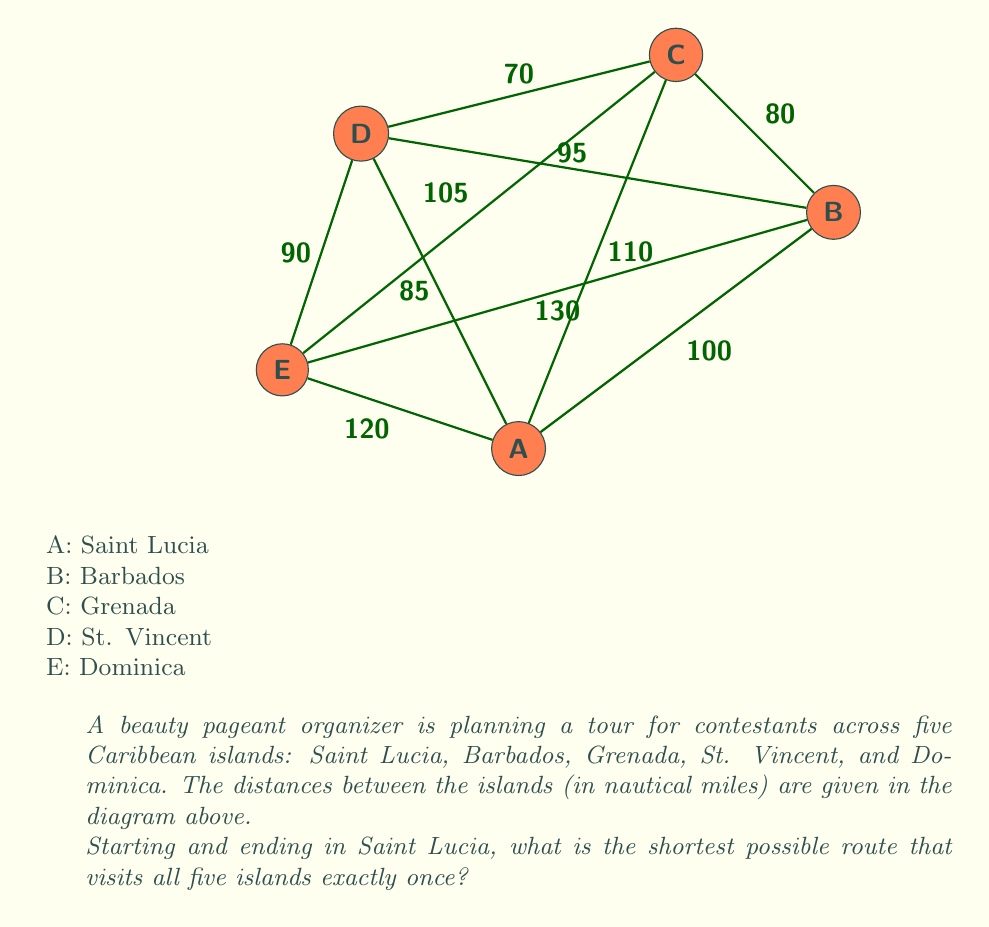Give your solution to this math problem. To solve this problem, we need to find the shortest Hamiltonian cycle in the given graph, which is known as the Traveling Salesman Problem (TSP). For a small number of nodes like this, we can use a brute-force approach.

Steps:
1) List all possible routes starting and ending in Saint Lucia (A):
   There are $(5-1)! = 24$ possible routes.

2) Calculate the total distance for each route:
   For example, A-B-C-D-E-A = 100 + 80 + 70 + 90 + 120 = 460 nm

3) Compare all routes and find the shortest one.

After calculating all routes, we find that the shortest route is:

A-D-C-B-E-A

Let's calculate its distance:
$$\begin{align*}
\text{A to D} &= 85 \text{ nm} \\
\text{D to C} &= 70 \text{ nm} \\
\text{C to B} &= 80 \text{ nm} \\
\text{B to E} &= 130 \text{ nm} \\
\text{E to A} &= 120 \text{ nm} \\
\text{Total} &= 85 + 70 + 80 + 130 + 120 = 485 \text{ nm}
\end{align*}$$

This route minimizes the total distance traveled while visiting all islands exactly once.
Answer: Saint Lucia - St. Vincent - Grenada - Barbados - Dominica - Saint Lucia (485 nm) 